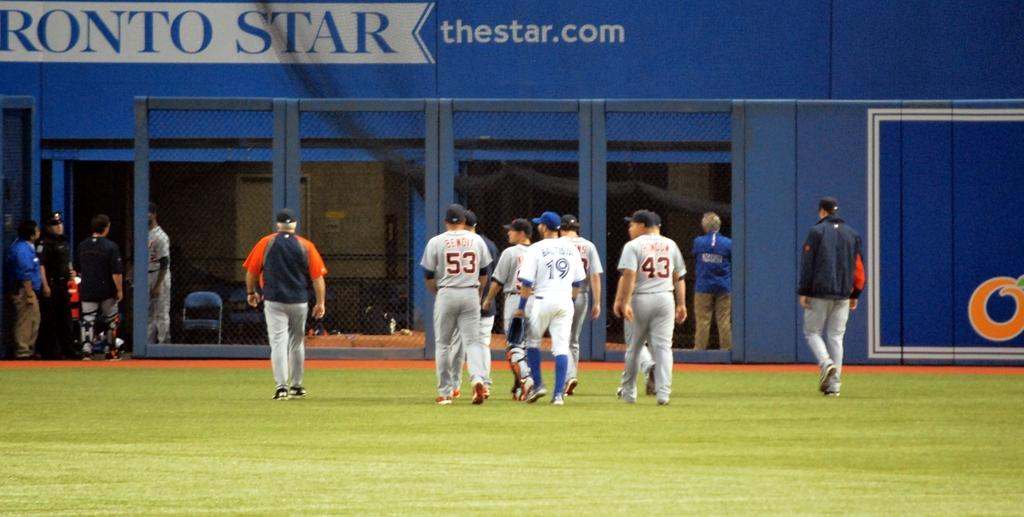Provide a one-sentence caption for the provided image. Several players with the numbers 53, 19 and 43 walking across the field. 